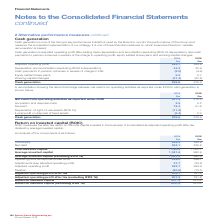According to Spirax Sarco Engineering Plc's financial document, How is cash generation data used by the Board? key performance indicators used by the Board to monitor the performance of the Group and measure the successful implementation of our strategy. It is one of three financial measures on which Executive Directors’ variable remuneration is based. The document states: "generation Cash generation is one of the Group’s key performance indicators used by the Board to monitor the performance of the Group and measure the ..." Also, How is cash generation calculated? adjusted operating profit after adding back depreciation and amortisation (excluding IFRS 16 depreciation), less cash payments to pension schemes in excess of the charge to operating profit, equity settled share plans and working capital changes. The document states: "Cash generation is adjusted operating profit after adding back depreciation and amortisation (excluding IFRS 16 depreciation), less cash payments to p..." Also, For which years was the cash generation calculated in? The document shows two values: 2019 and 2018. From the document: "Spirax-Sarco Engineering plc Annual Report 2019 2018 £m Adjusted operating profit 282.7 264.9 Depreciation and amortisation (excluding IFRS16 deprecia..." Additionally, In which year was the amount of adjusted operating profit larger? According to the financial document, 2019. The relevant text states: "Spirax-Sarco Engineering plc Annual Report 2019..." Also, can you calculate: What was the change in equity settled share plans in 2019 from 2018? Based on the calculation: 6.2-5.7, the result is 0.5 (in millions). This is based on the information: "to P&L (5.2) (4.6) Equity settled share plans 6.2 5.7 rge to P&L (5.2) (4.6) Equity settled share plans 6.2 5.7..." The key data points involved are: 5.7, 6.2. Also, can you calculate: What was the percentage change in equity settled share plans in 2019 from 2018? To answer this question, I need to perform calculations using the financial data. The calculation is: (6.2-5.7)/5.7, which equals 8.77 (percentage). This is based on the information: "to P&L (5.2) (4.6) Equity settled share plans 6.2 5.7 rge to P&L (5.2) (4.6) Equity settled share plans 6.2 5.7..." The key data points involved are: 5.7, 6.2. 